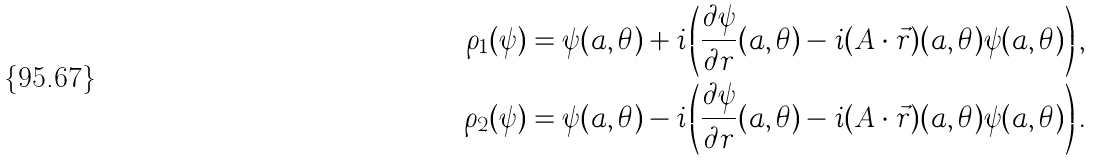Convert formula to latex. <formula><loc_0><loc_0><loc_500><loc_500>\rho _ { 1 } ( \psi ) & = \psi ( a , \theta ) + i \left ( \frac { \partial \psi } { \partial r } ( a , \theta ) - i ( { A } \cdot \vec { r } ) ( a , \theta ) \psi ( a , \theta ) \right ) , \\ \rho _ { 2 } ( \psi ) & = \psi ( a , \theta ) - i \left ( \frac { \partial \psi } { \partial r } ( a , \theta ) - i ( { A } \cdot \vec { r } ) ( a , \theta ) \psi ( a , \theta ) \right ) .</formula> 